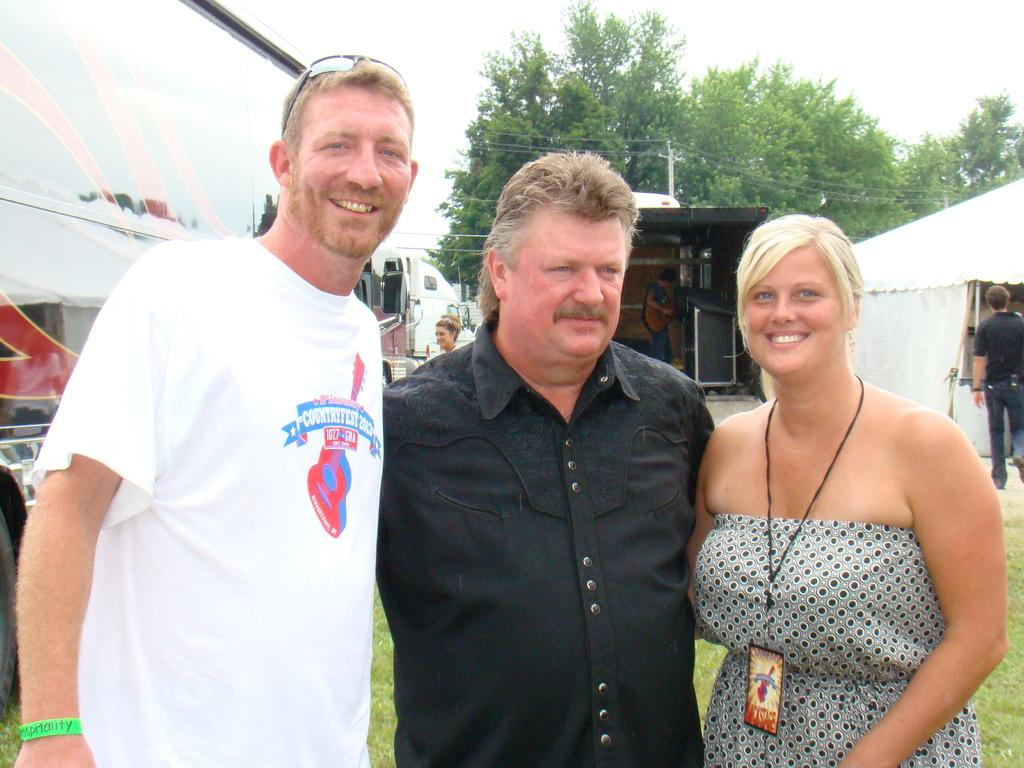How many people are in the image? There are people in the image, but the exact number is not specified. What is the lady wearing in the image? The lady is wearing an access card in the image. What type of vehicles can be seen in the image? There are vehicles in the image, but the specific types are not mentioned. What structure is present in the image? There is a tent in the image. What is the pole used for in the image? The purpose of the pole in the image is not specified. What are the wires connected to in the image? The wires in the image are not connected to any specific object or structure. What type of vegetation is visible in the image? Trees are visible in the image. What part of the natural environment is visible in the image? The sky is visible in the image. What shape is the calendar in the image? There is no calendar present in the image. What type of sink is visible in the image? There is no sink present in the image. 